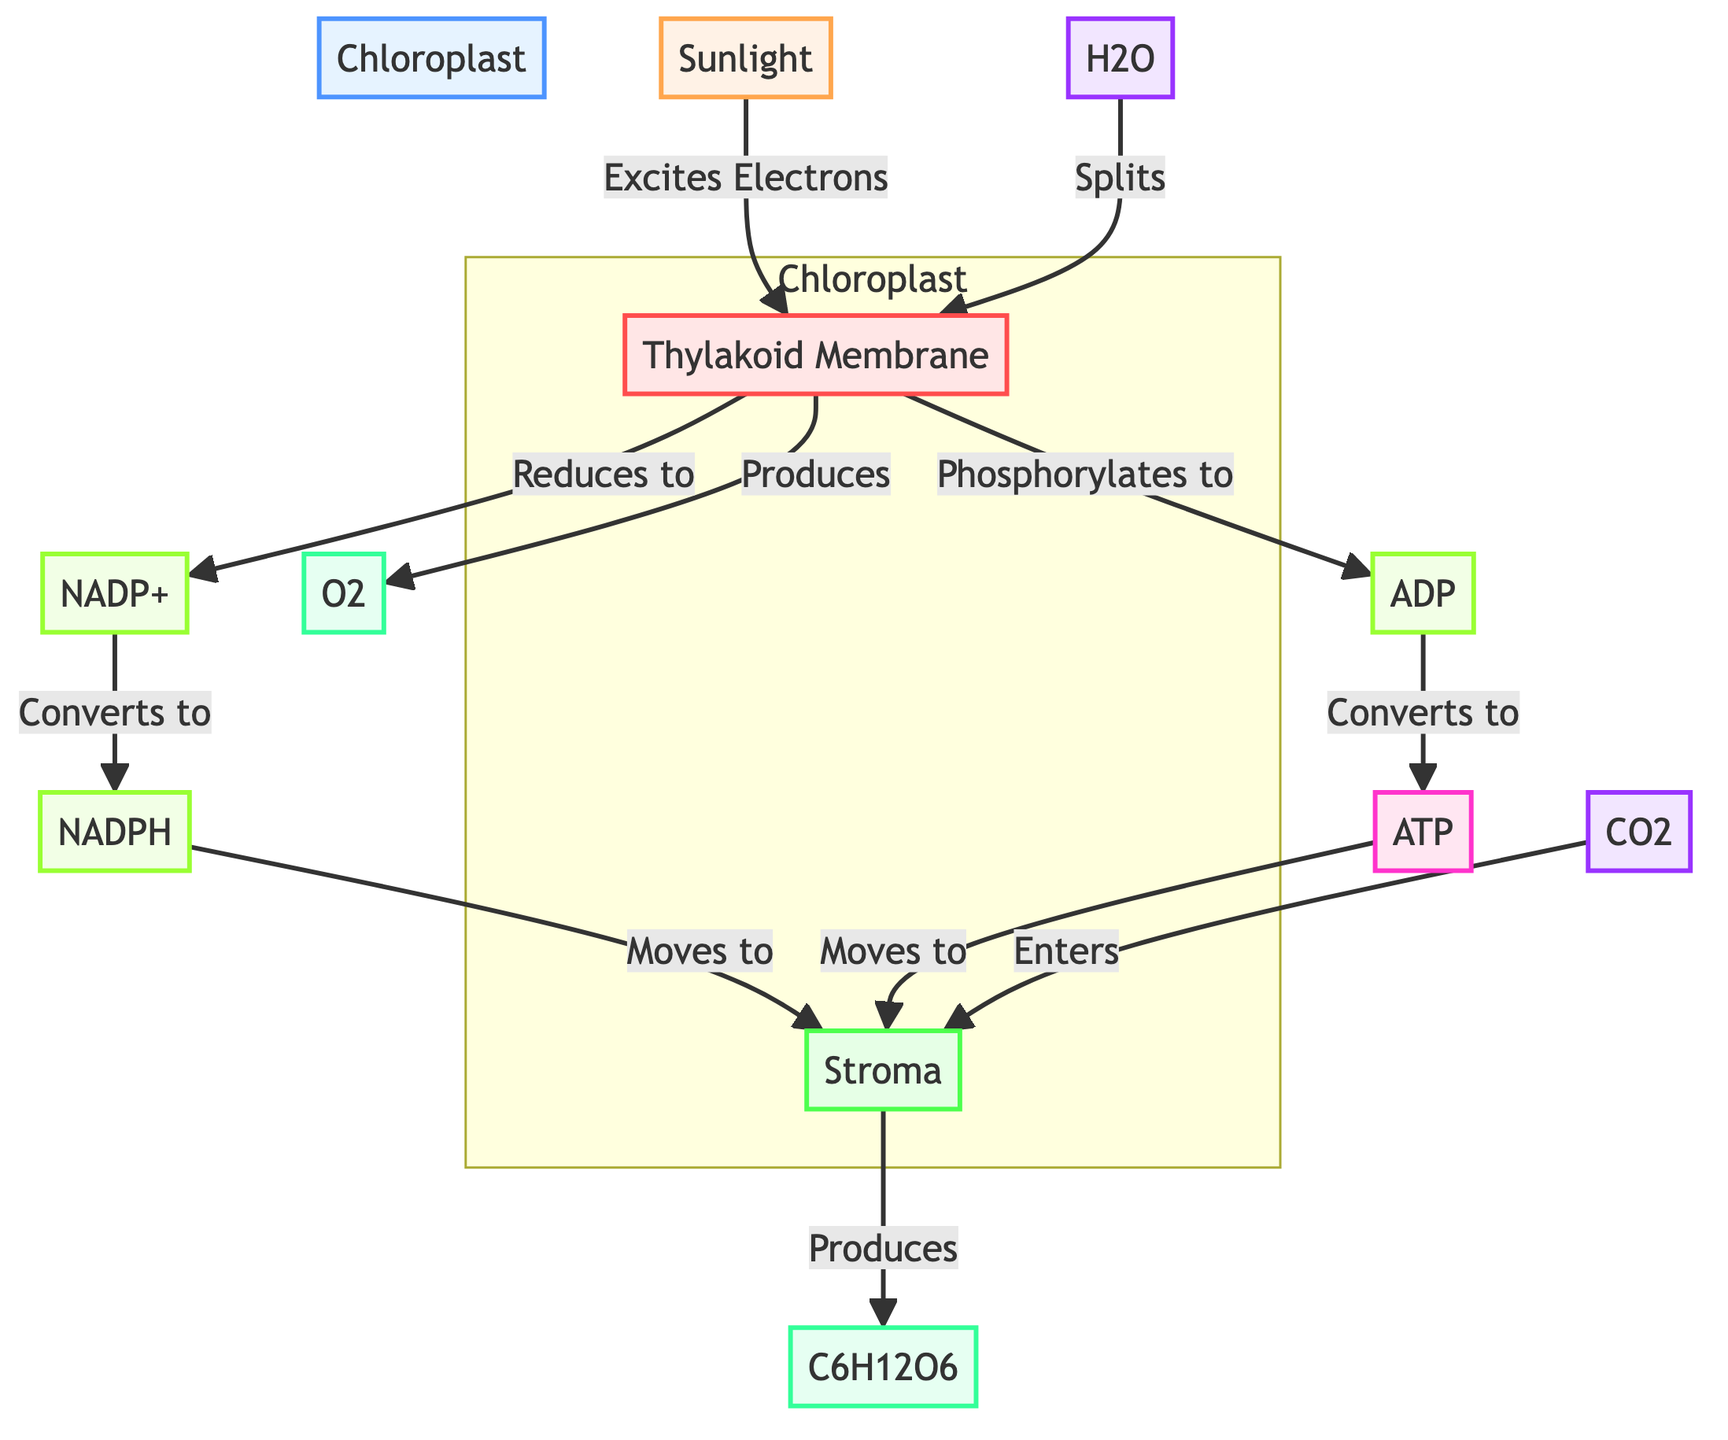What is the main organelle involved in the photosynthesis process? The diagram highlights the "Chloroplast" as the central organelle where photosynthesis occurs, as it is the only prominent organelle labeled.
Answer: Chloroplast What is produced as a result of the light-dependent reactions? The flow in the diagram indicates that "O2" is a product of the processes occurring in the "Thylakoid Membrane" during light-dependent reactions.
Answer: O2 How many types of energy carriers are mentioned in the diagram? The diagram includes two energy carriers: "NADPH" and "ATP," making a total of two distinct energy carriers used in the photosynthesis process.
Answer: 2 What is the relationship between ADP and ATP in this diagram? The arrows show that "ADP" is converted and "Phosphorylates to" become "ATP," indicating a transformation from one molecule to another.
Answer: Converts to What enters the stroma to participate in the light-independent reactions? The diagram specifies that "CO2" enters the "Stroma" to participate in the light-independent reactions, emphasizing its importance in the process.
Answer: CO2 What reduces NADP+ in the light-dependent reactions? The arrows in the diagram illustrate that the "Thylakoid Membrane" is responsible for the reduction of NADP+ to NADPH, completing the connection by indicating where the reduction occurs.
Answer: Thylakoid Membrane Which molecule acts as the energy source in the photosynthesis process? "Sunlight" is specifically labeled as the energy source that drives the reactions in this diagram, highlighting its role in powering the process.
Answer: Sunlight What is the final product formed in the stroma? In the "Stroma," the diagram explicitly states that "C6H12O6," or glucose, is produced, showing it as the endpoint of the light-independent reactions.
Answer: C6H12O6 How is water involved in the light-dependent reactions? The diagram indicates that "H2O" splits in the "Thylakoid Membrane," which shows its active role in the initial stage of the light-dependent reactions, leading to the production of other molecules.
Answer: Splits 